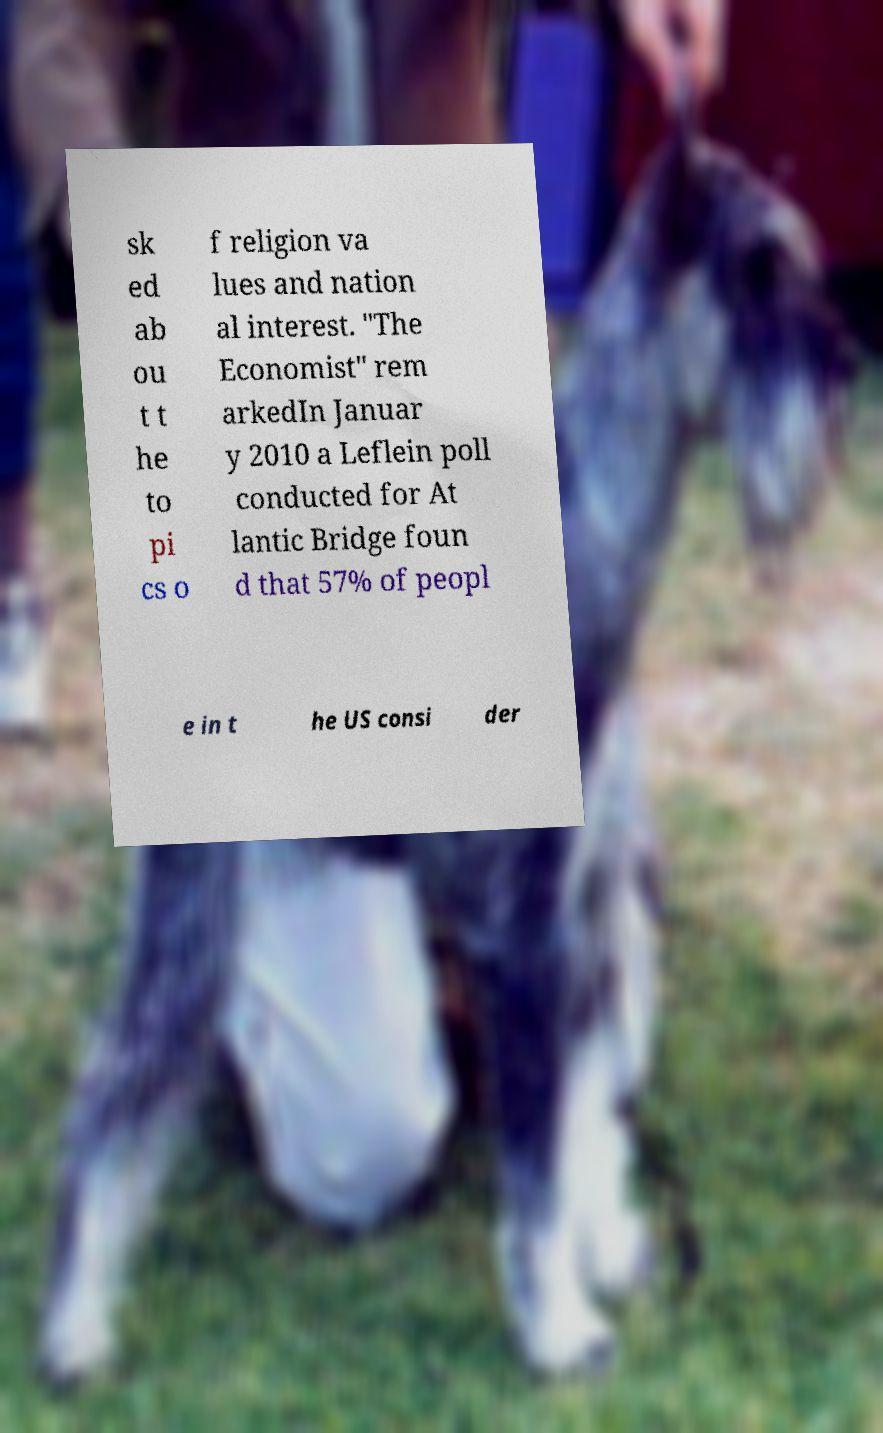Could you assist in decoding the text presented in this image and type it out clearly? sk ed ab ou t t he to pi cs o f religion va lues and nation al interest. "The Economist" rem arkedIn Januar y 2010 a Leflein poll conducted for At lantic Bridge foun d that 57% of peopl e in t he US consi der 